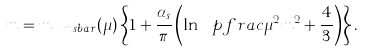<formula> <loc_0><loc_0><loc_500><loc_500>m = m _ { \ m s b a r } ( \mu ) \left \{ 1 + \frac { \alpha _ { s } } \pi \left ( \ln \ p f r a c { \mu ^ { 2 } } { m ^ { 2 } } + \frac { 4 } { 3 } \right ) \right \} .</formula> 